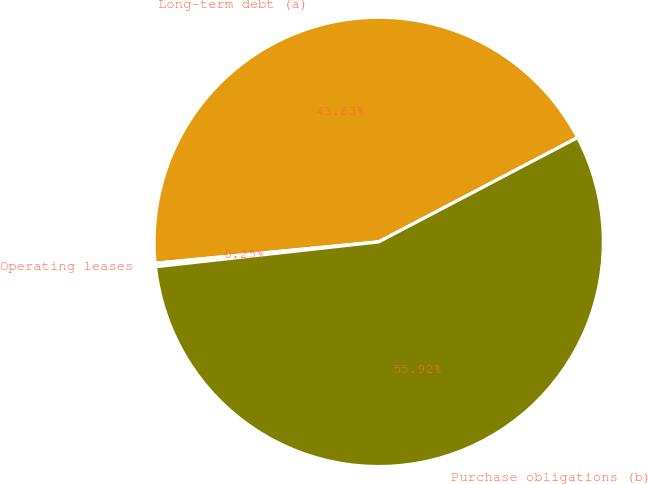<chart> <loc_0><loc_0><loc_500><loc_500><pie_chart><fcel>Long-term debt (a)<fcel>Operating leases<fcel>Purchase obligations (b)<nl><fcel>43.83%<fcel>0.25%<fcel>55.92%<nl></chart> 